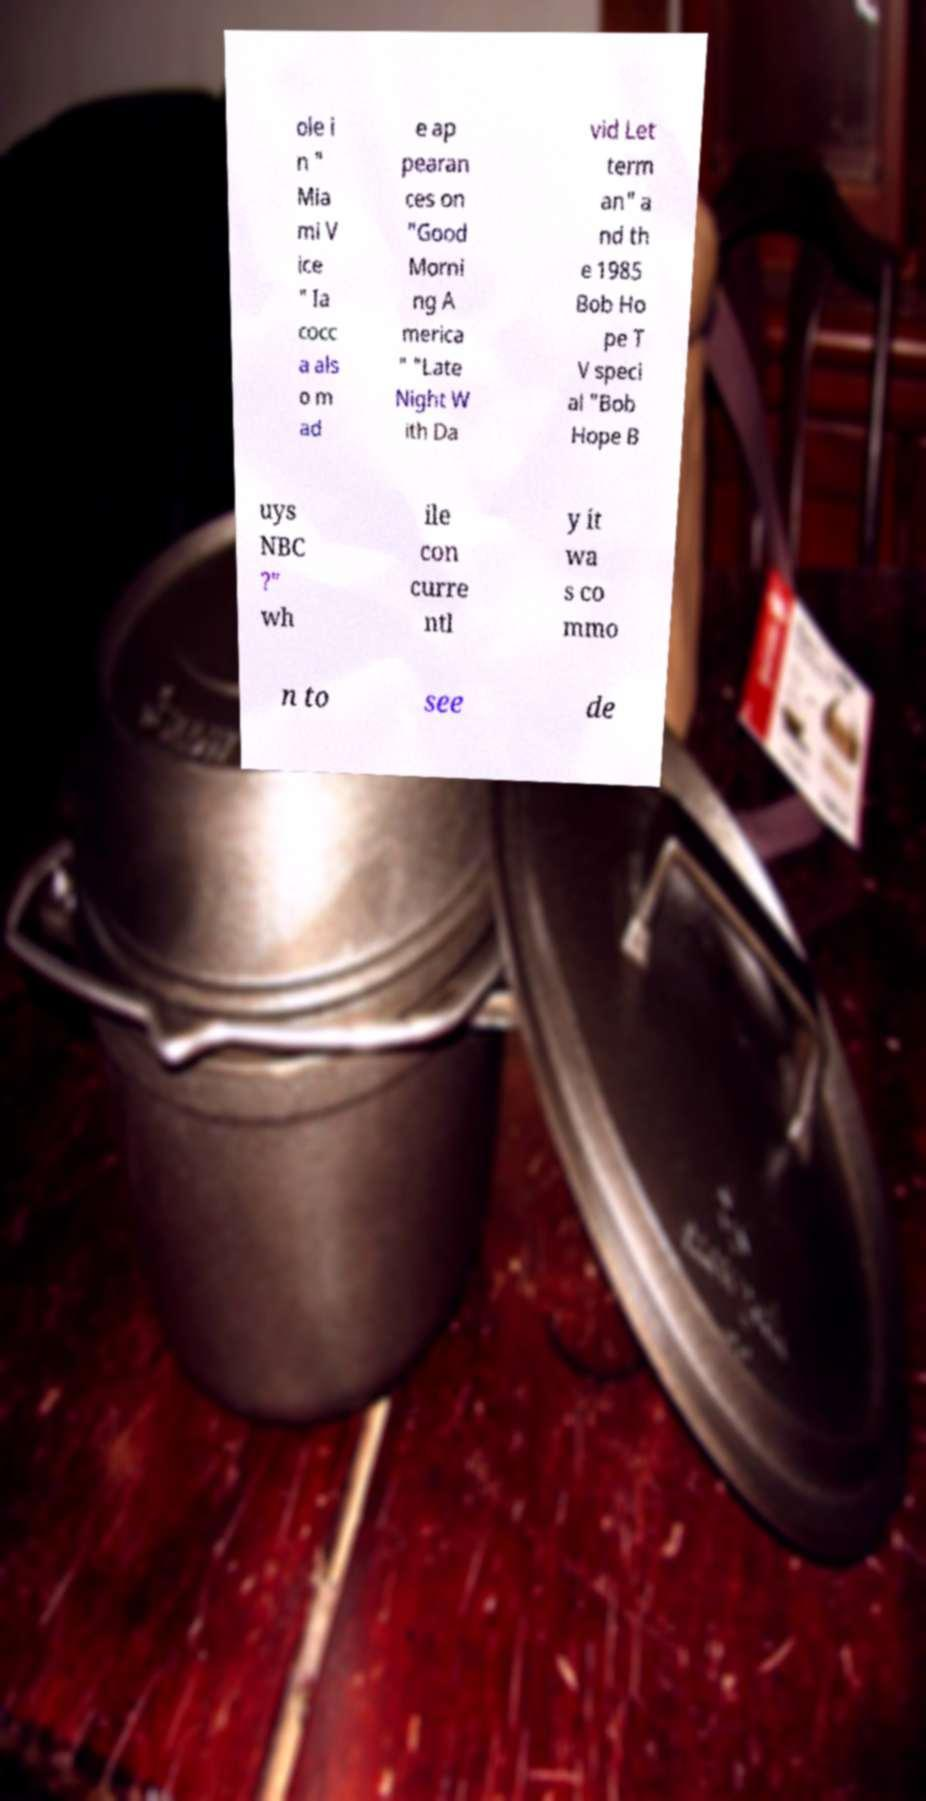There's text embedded in this image that I need extracted. Can you transcribe it verbatim? ole i n " Mia mi V ice " Ia cocc a als o m ad e ap pearan ces on "Good Morni ng A merica " "Late Night W ith Da vid Let term an" a nd th e 1985 Bob Ho pe T V speci al "Bob Hope B uys NBC ?" wh ile con curre ntl y it wa s co mmo n to see de 